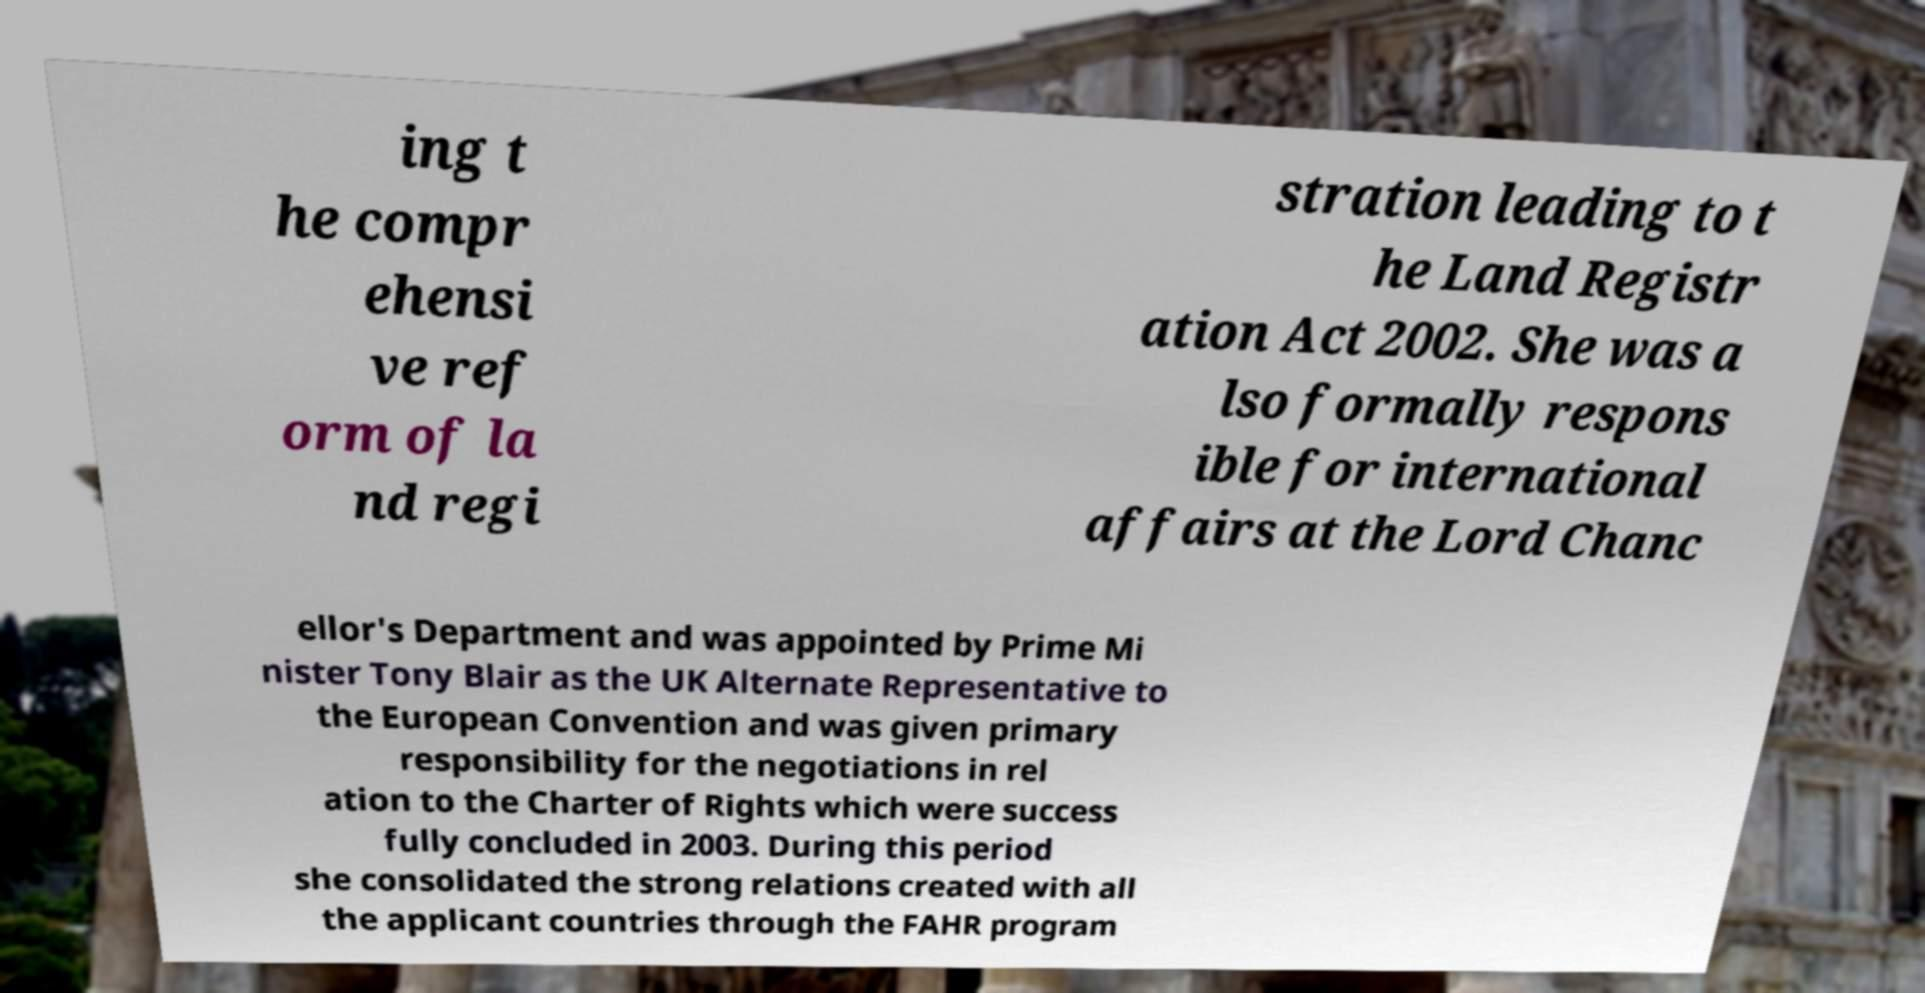What messages or text are displayed in this image? I need them in a readable, typed format. ing t he compr ehensi ve ref orm of la nd regi stration leading to t he Land Registr ation Act 2002. She was a lso formally respons ible for international affairs at the Lord Chanc ellor's Department and was appointed by Prime Mi nister Tony Blair as the UK Alternate Representative to the European Convention and was given primary responsibility for the negotiations in rel ation to the Charter of Rights which were success fully concluded in 2003. During this period she consolidated the strong relations created with all the applicant countries through the FAHR program 